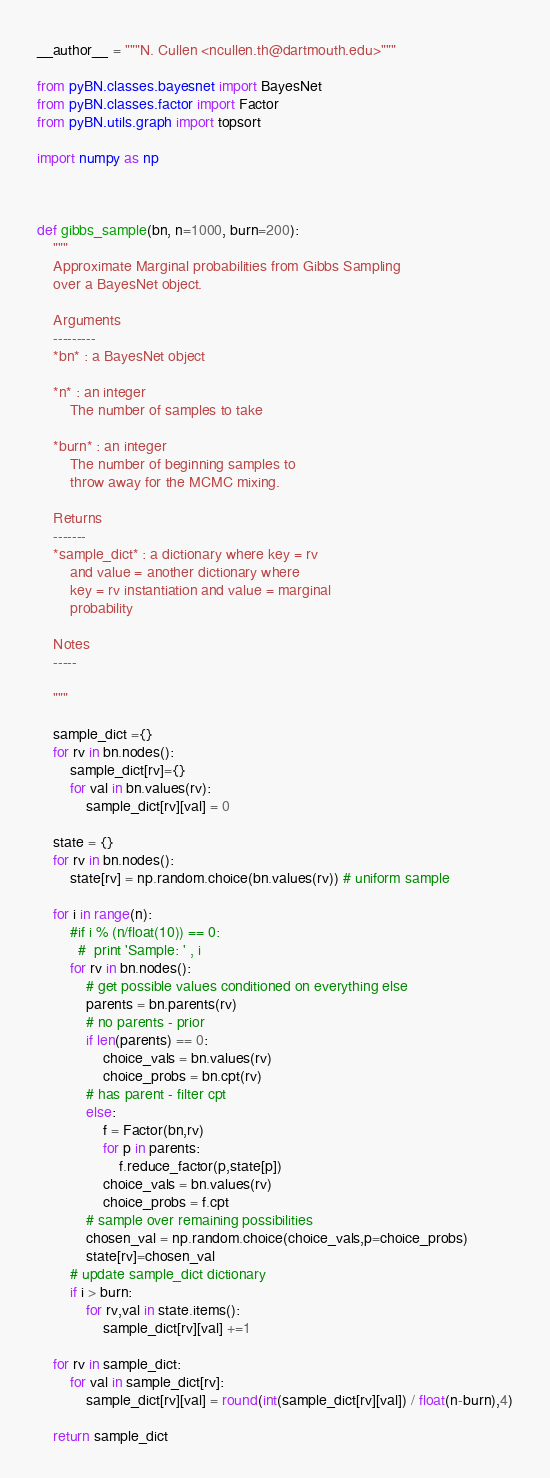<code> <loc_0><loc_0><loc_500><loc_500><_Python_>
__author__ = """N. Cullen <ncullen.th@dartmouth.edu>"""

from pyBN.classes.bayesnet import BayesNet
from pyBN.classes.factor import Factor 
from pyBN.utils.graph import topsort

import numpy as np



def gibbs_sample(bn, n=1000, burn=200):
	"""
	Approximate Marginal probabilities from Gibbs Sampling
	over a BayesNet object.

	Arguments
	---------
	*bn* : a BayesNet object

	*n* : an integer
		The number of samples to take

	*burn* : an integer
		The number of beginning samples to
		throw away for the MCMC mixing.

	Returns
	-------
	*sample_dict* : a dictionary where key = rv
		and value = another dictionary where
		key = rv instantiation and value = marginal
		probability

	Notes
	-----

	"""

	sample_dict ={}
	for rv in bn.nodes():
	    sample_dict[rv]={}
	    for val in bn.values(rv):
	        sample_dict[rv][val] = 0

	state = {}
	for rv in bn.nodes():
	    state[rv] = np.random.choice(bn.values(rv)) # uniform sample

	for i in range(n):
	    #if i % (n/float(10)) == 0:
	      #  print 'Sample: ' , i
	    for rv in bn.nodes():
	        # get possible values conditioned on everything else
	        parents = bn.parents(rv)
	        # no parents - prior
	        if len(parents) == 0:
	            choice_vals = bn.values(rv)
	            choice_probs = bn.cpt(rv)
	        # has parent - filter cpt
	        else:
	            f = Factor(bn,rv)
	            for p in parents:
	                f.reduce_factor(p,state[p])
	            choice_vals = bn.values(rv)
	            choice_probs = f.cpt
	        # sample over remaining possibilities
	        chosen_val = np.random.choice(choice_vals,p=choice_probs)
	        state[rv]=chosen_val
	    # update sample_dict dictionary
	    if i > burn:
	        for rv,val in state.items():
	            sample_dict[rv][val] +=1

	for rv in sample_dict:
	    for val in sample_dict[rv]:
	        sample_dict[rv][val] = round(int(sample_dict[rv][val]) / float(n-burn),4)
	
	return sample_dict</code> 